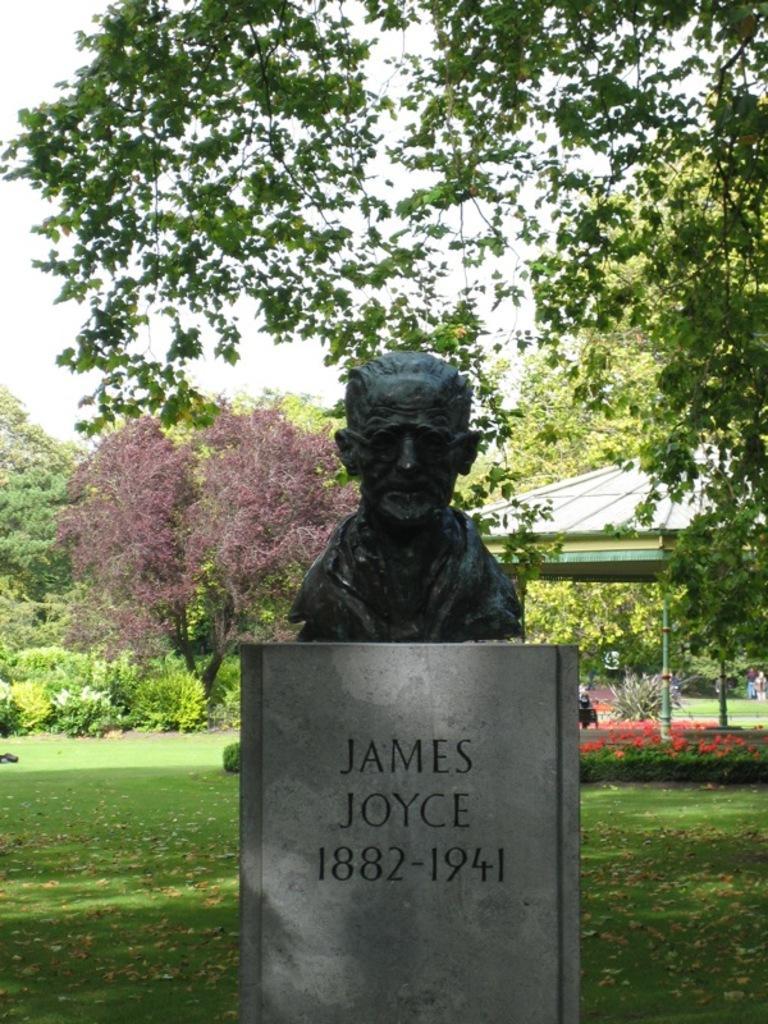Please provide a concise description of this image. In this image I can see a statue and something written on the stone. In the background I can see trees, the sky, the grass and some objects on the ground. 